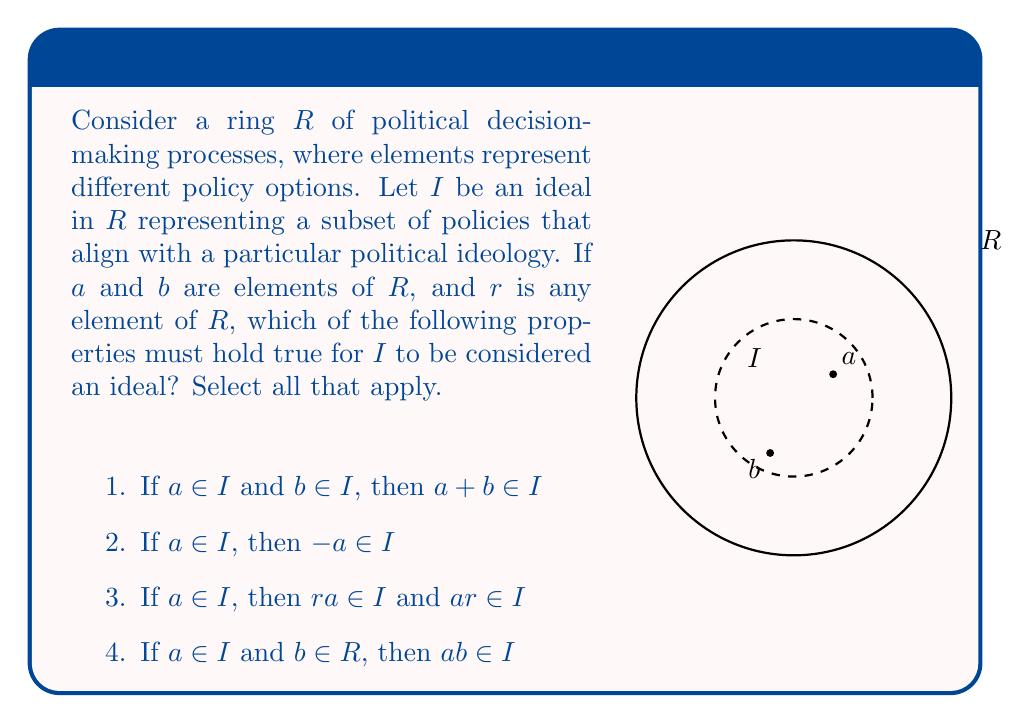Can you solve this math problem? To analyze this question, let's consider each property in the context of political decision-making processes:

1) $a + b \in I$ if $a \in I$ and $b \in I$:
   This property must hold for an ideal. In political terms, if two policies ($a$ and $b$) align with a particular ideology ($I$), their combination should also align with that ideology.

2) $-a \in I$ if $a \in I$:
   This property must hold for an ideal. In political terms, if a policy ($a$) aligns with an ideology ($I$), its opposite or negation ($-a$) should also be considered within the scope of that ideological framework.

3) $ra \in I$ and $ar \in I$ if $a \in I$ and $r \in R$:
   This property must hold for an ideal. It means that if a policy ($a$) aligns with an ideology ($I$), any modification or combination of that policy with any other political process ($r$) should still align with the ideology.

4) $ab \in I$ if $a \in I$ and $b \in R$:
   This property is not necessary for an ideal. In political terms, it would mean that combining a policy aligned with the ideology ($a \in I$) with any other policy ($b \in R$) would always result in a policy aligned with the ideology. This is too restrictive and doesn't reflect real-world political dynamics.

Therefore, properties 1, 2, and 3 must hold for $I$ to be an ideal in the ring $R$ of political decision-making processes.
Answer: Properties 1, 2, and 3 